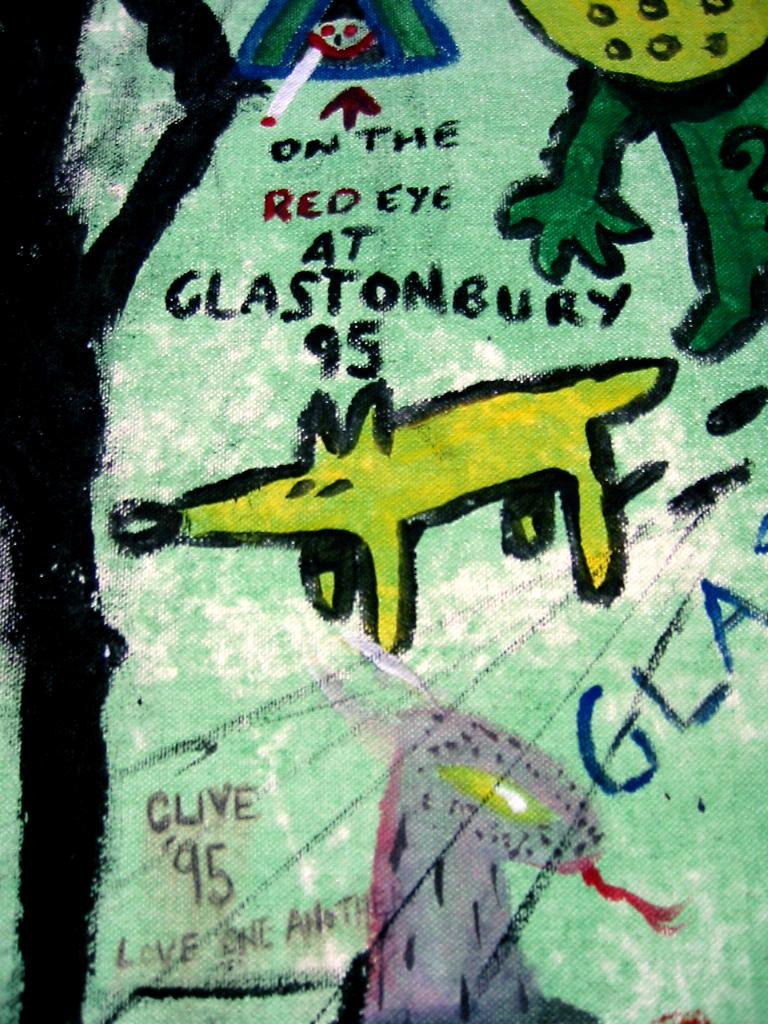<image>
Describe the image concisely. A cartoon drawing of the famous Glastonbury festival. 